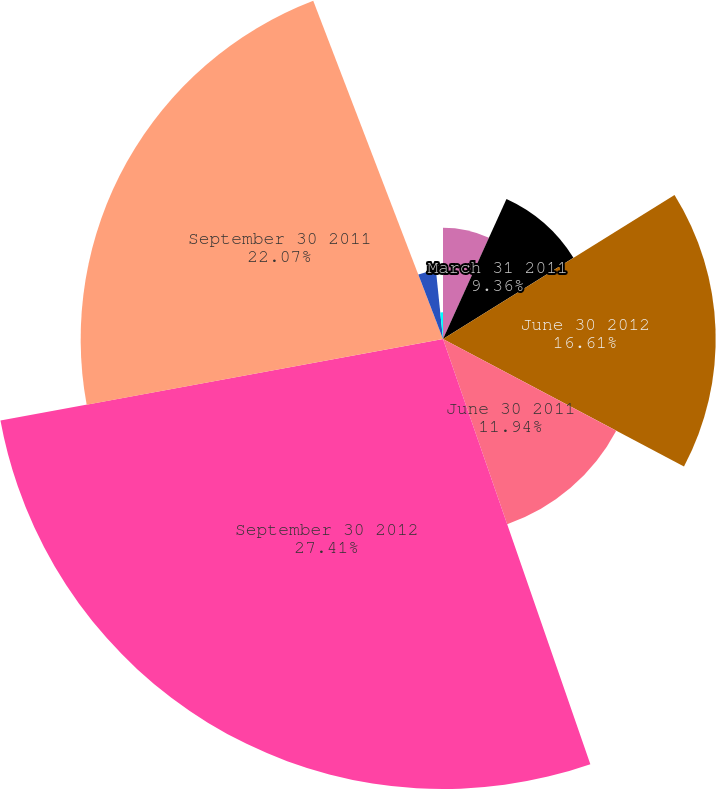Convert chart. <chart><loc_0><loc_0><loc_500><loc_500><pie_chart><fcel>March 31 2012<fcel>March 31 2011<fcel>June 30 2012<fcel>June 30 2011<fcel>September 30 2012<fcel>September 30 2011<fcel>December 31 2012<fcel>December 31 2011<nl><fcel>6.78%<fcel>9.36%<fcel>16.61%<fcel>11.94%<fcel>27.41%<fcel>22.07%<fcel>4.2%<fcel>1.63%<nl></chart> 